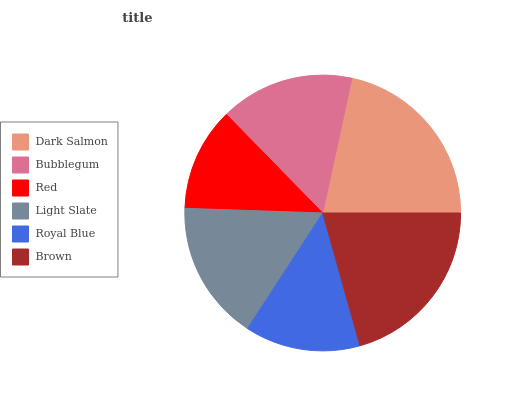Is Red the minimum?
Answer yes or no. Yes. Is Dark Salmon the maximum?
Answer yes or no. Yes. Is Bubblegum the minimum?
Answer yes or no. No. Is Bubblegum the maximum?
Answer yes or no. No. Is Dark Salmon greater than Bubblegum?
Answer yes or no. Yes. Is Bubblegum less than Dark Salmon?
Answer yes or no. Yes. Is Bubblegum greater than Dark Salmon?
Answer yes or no. No. Is Dark Salmon less than Bubblegum?
Answer yes or no. No. Is Light Slate the high median?
Answer yes or no. Yes. Is Bubblegum the low median?
Answer yes or no. Yes. Is Red the high median?
Answer yes or no. No. Is Royal Blue the low median?
Answer yes or no. No. 